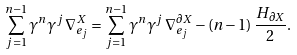<formula> <loc_0><loc_0><loc_500><loc_500>\sum _ { j = 1 } ^ { n - 1 } \gamma ^ { n } \gamma ^ { j } \, \nabla ^ { X } _ { e _ { j } } = \sum _ { j = 1 } ^ { n - 1 } \gamma ^ { n } \gamma ^ { j } \, \nabla ^ { \partial X } _ { e _ { j } } - ( n - 1 ) \, \frac { H _ { \partial X } } { 2 } .</formula> 